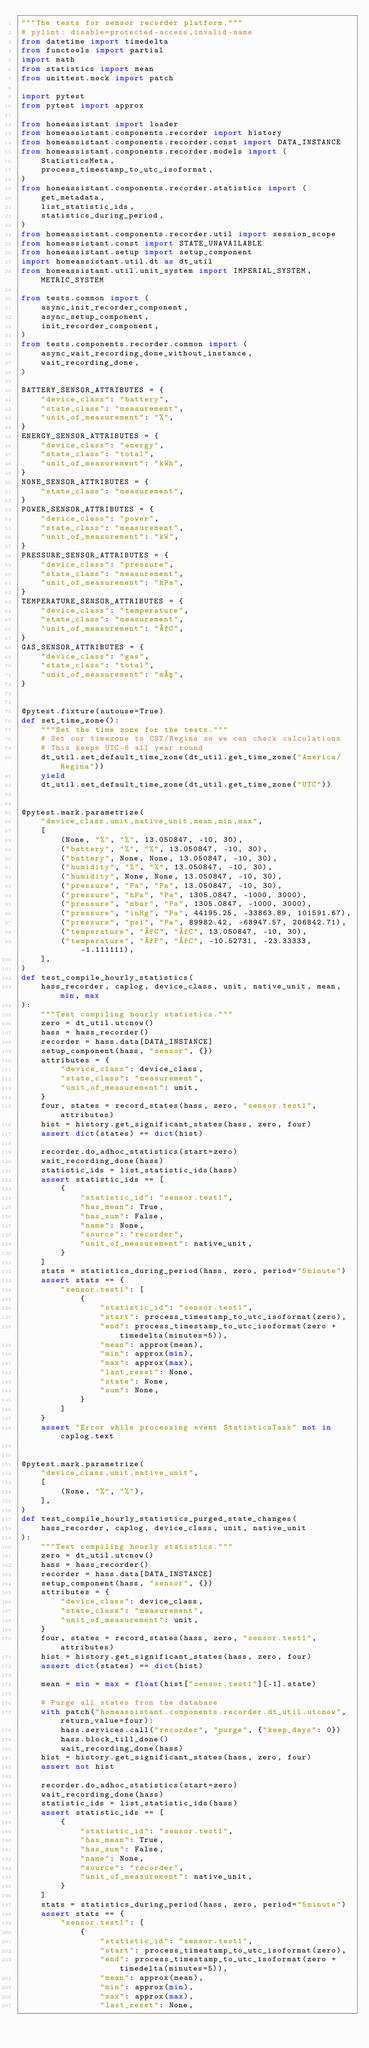Convert code to text. <code><loc_0><loc_0><loc_500><loc_500><_Python_>"""The tests for sensor recorder platform."""
# pylint: disable=protected-access,invalid-name
from datetime import timedelta
from functools import partial
import math
from statistics import mean
from unittest.mock import patch

import pytest
from pytest import approx

from homeassistant import loader
from homeassistant.components.recorder import history
from homeassistant.components.recorder.const import DATA_INSTANCE
from homeassistant.components.recorder.models import (
    StatisticsMeta,
    process_timestamp_to_utc_isoformat,
)
from homeassistant.components.recorder.statistics import (
    get_metadata,
    list_statistic_ids,
    statistics_during_period,
)
from homeassistant.components.recorder.util import session_scope
from homeassistant.const import STATE_UNAVAILABLE
from homeassistant.setup import setup_component
import homeassistant.util.dt as dt_util
from homeassistant.util.unit_system import IMPERIAL_SYSTEM, METRIC_SYSTEM

from tests.common import (
    async_init_recorder_component,
    async_setup_component,
    init_recorder_component,
)
from tests.components.recorder.common import (
    async_wait_recording_done_without_instance,
    wait_recording_done,
)

BATTERY_SENSOR_ATTRIBUTES = {
    "device_class": "battery",
    "state_class": "measurement",
    "unit_of_measurement": "%",
}
ENERGY_SENSOR_ATTRIBUTES = {
    "device_class": "energy",
    "state_class": "total",
    "unit_of_measurement": "kWh",
}
NONE_SENSOR_ATTRIBUTES = {
    "state_class": "measurement",
}
POWER_SENSOR_ATTRIBUTES = {
    "device_class": "power",
    "state_class": "measurement",
    "unit_of_measurement": "kW",
}
PRESSURE_SENSOR_ATTRIBUTES = {
    "device_class": "pressure",
    "state_class": "measurement",
    "unit_of_measurement": "hPa",
}
TEMPERATURE_SENSOR_ATTRIBUTES = {
    "device_class": "temperature",
    "state_class": "measurement",
    "unit_of_measurement": "°C",
}
GAS_SENSOR_ATTRIBUTES = {
    "device_class": "gas",
    "state_class": "total",
    "unit_of_measurement": "m³",
}


@pytest.fixture(autouse=True)
def set_time_zone():
    """Set the time zone for the tests."""
    # Set our timezone to CST/Regina so we can check calculations
    # This keeps UTC-6 all year round
    dt_util.set_default_time_zone(dt_util.get_time_zone("America/Regina"))
    yield
    dt_util.set_default_time_zone(dt_util.get_time_zone("UTC"))


@pytest.mark.parametrize(
    "device_class,unit,native_unit,mean,min,max",
    [
        (None, "%", "%", 13.050847, -10, 30),
        ("battery", "%", "%", 13.050847, -10, 30),
        ("battery", None, None, 13.050847, -10, 30),
        ("humidity", "%", "%", 13.050847, -10, 30),
        ("humidity", None, None, 13.050847, -10, 30),
        ("pressure", "Pa", "Pa", 13.050847, -10, 30),
        ("pressure", "hPa", "Pa", 1305.0847, -1000, 3000),
        ("pressure", "mbar", "Pa", 1305.0847, -1000, 3000),
        ("pressure", "inHg", "Pa", 44195.25, -33863.89, 101591.67),
        ("pressure", "psi", "Pa", 89982.42, -68947.57, 206842.71),
        ("temperature", "°C", "°C", 13.050847, -10, 30),
        ("temperature", "°F", "°C", -10.52731, -23.33333, -1.111111),
    ],
)
def test_compile_hourly_statistics(
    hass_recorder, caplog, device_class, unit, native_unit, mean, min, max
):
    """Test compiling hourly statistics."""
    zero = dt_util.utcnow()
    hass = hass_recorder()
    recorder = hass.data[DATA_INSTANCE]
    setup_component(hass, "sensor", {})
    attributes = {
        "device_class": device_class,
        "state_class": "measurement",
        "unit_of_measurement": unit,
    }
    four, states = record_states(hass, zero, "sensor.test1", attributes)
    hist = history.get_significant_states(hass, zero, four)
    assert dict(states) == dict(hist)

    recorder.do_adhoc_statistics(start=zero)
    wait_recording_done(hass)
    statistic_ids = list_statistic_ids(hass)
    assert statistic_ids == [
        {
            "statistic_id": "sensor.test1",
            "has_mean": True,
            "has_sum": False,
            "name": None,
            "source": "recorder",
            "unit_of_measurement": native_unit,
        }
    ]
    stats = statistics_during_period(hass, zero, period="5minute")
    assert stats == {
        "sensor.test1": [
            {
                "statistic_id": "sensor.test1",
                "start": process_timestamp_to_utc_isoformat(zero),
                "end": process_timestamp_to_utc_isoformat(zero + timedelta(minutes=5)),
                "mean": approx(mean),
                "min": approx(min),
                "max": approx(max),
                "last_reset": None,
                "state": None,
                "sum": None,
            }
        ]
    }
    assert "Error while processing event StatisticsTask" not in caplog.text


@pytest.mark.parametrize(
    "device_class,unit,native_unit",
    [
        (None, "%", "%"),
    ],
)
def test_compile_hourly_statistics_purged_state_changes(
    hass_recorder, caplog, device_class, unit, native_unit
):
    """Test compiling hourly statistics."""
    zero = dt_util.utcnow()
    hass = hass_recorder()
    recorder = hass.data[DATA_INSTANCE]
    setup_component(hass, "sensor", {})
    attributes = {
        "device_class": device_class,
        "state_class": "measurement",
        "unit_of_measurement": unit,
    }
    four, states = record_states(hass, zero, "sensor.test1", attributes)
    hist = history.get_significant_states(hass, zero, four)
    assert dict(states) == dict(hist)

    mean = min = max = float(hist["sensor.test1"][-1].state)

    # Purge all states from the database
    with patch("homeassistant.components.recorder.dt_util.utcnow", return_value=four):
        hass.services.call("recorder", "purge", {"keep_days": 0})
        hass.block_till_done()
        wait_recording_done(hass)
    hist = history.get_significant_states(hass, zero, four)
    assert not hist

    recorder.do_adhoc_statistics(start=zero)
    wait_recording_done(hass)
    statistic_ids = list_statistic_ids(hass)
    assert statistic_ids == [
        {
            "statistic_id": "sensor.test1",
            "has_mean": True,
            "has_sum": False,
            "name": None,
            "source": "recorder",
            "unit_of_measurement": native_unit,
        }
    ]
    stats = statistics_during_period(hass, zero, period="5minute")
    assert stats == {
        "sensor.test1": [
            {
                "statistic_id": "sensor.test1",
                "start": process_timestamp_to_utc_isoformat(zero),
                "end": process_timestamp_to_utc_isoformat(zero + timedelta(minutes=5)),
                "mean": approx(mean),
                "min": approx(min),
                "max": approx(max),
                "last_reset": None,</code> 